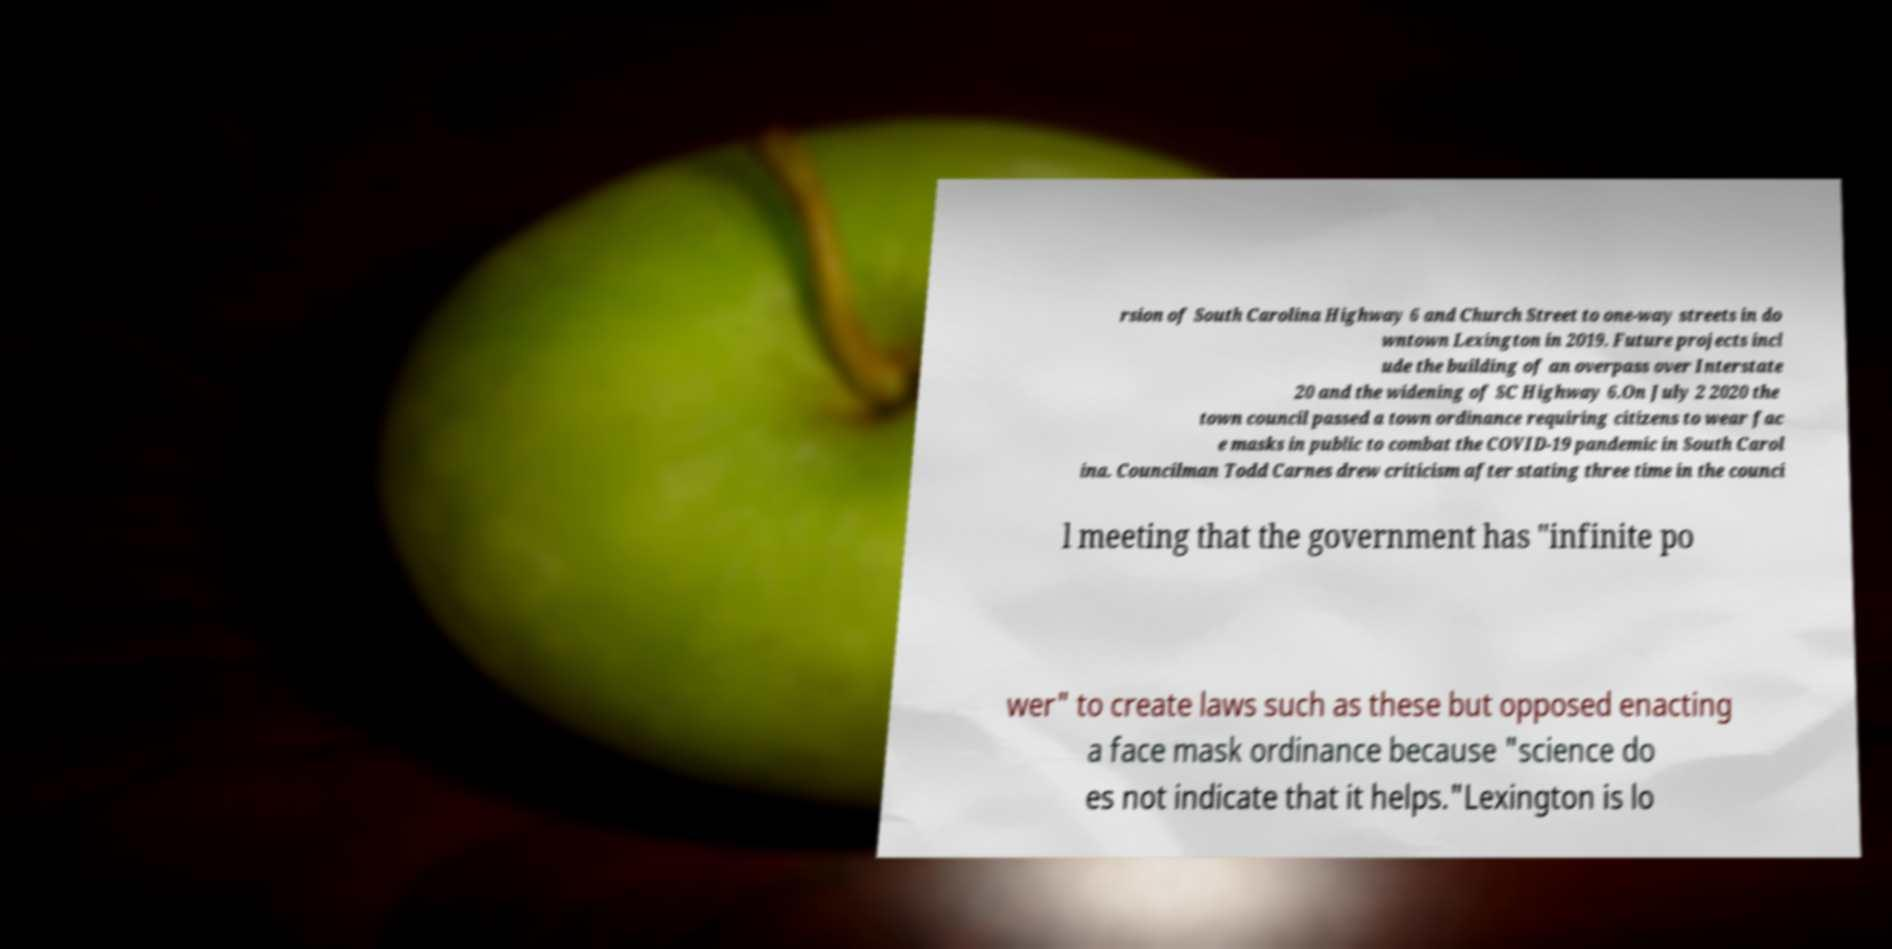Could you assist in decoding the text presented in this image and type it out clearly? rsion of South Carolina Highway 6 and Church Street to one-way streets in do wntown Lexington in 2019. Future projects incl ude the building of an overpass over Interstate 20 and the widening of SC Highway 6.On July 2 2020 the town council passed a town ordinance requiring citizens to wear fac e masks in public to combat the COVID-19 pandemic in South Carol ina. Councilman Todd Carnes drew criticism after stating three time in the counci l meeting that the government has "infinite po wer" to create laws such as these but opposed enacting a face mask ordinance because "science do es not indicate that it helps."Lexington is lo 